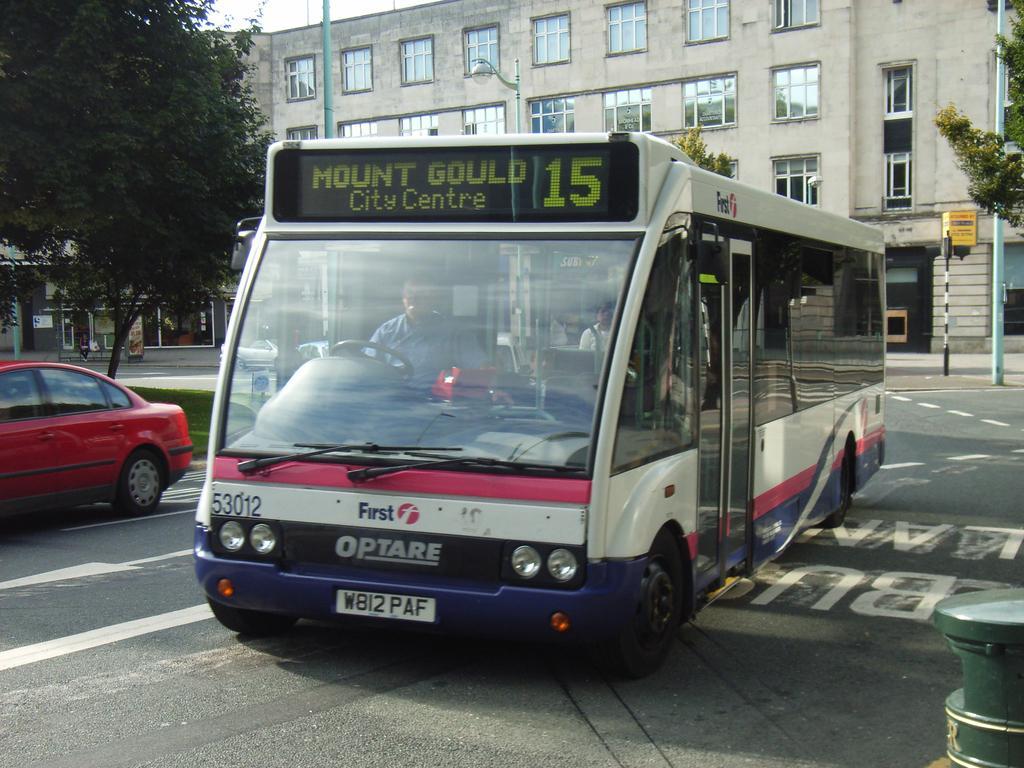Describe this image in one or two sentences. In front of the picture, we see a man riding a bus. At the bottom, we see the road. In the right bottom, we see a green color pole. On the left side, we see a red car. Beside that, we see the grass and a tree. On the right side, we see the poles and a tree. There are trees and the buildings in the background. 